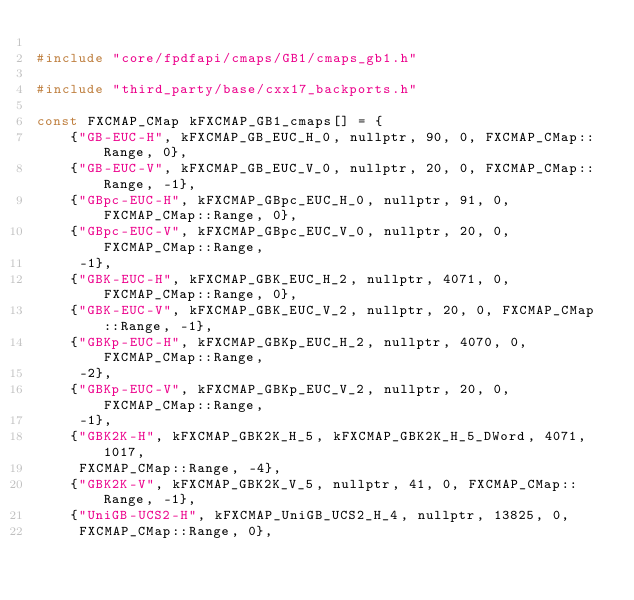<code> <loc_0><loc_0><loc_500><loc_500><_C++_>
#include "core/fpdfapi/cmaps/GB1/cmaps_gb1.h"

#include "third_party/base/cxx17_backports.h"

const FXCMAP_CMap kFXCMAP_GB1_cmaps[] = {
    {"GB-EUC-H", kFXCMAP_GB_EUC_H_0, nullptr, 90, 0, FXCMAP_CMap::Range, 0},
    {"GB-EUC-V", kFXCMAP_GB_EUC_V_0, nullptr, 20, 0, FXCMAP_CMap::Range, -1},
    {"GBpc-EUC-H", kFXCMAP_GBpc_EUC_H_0, nullptr, 91, 0, FXCMAP_CMap::Range, 0},
    {"GBpc-EUC-V", kFXCMAP_GBpc_EUC_V_0, nullptr, 20, 0, FXCMAP_CMap::Range,
     -1},
    {"GBK-EUC-H", kFXCMAP_GBK_EUC_H_2, nullptr, 4071, 0, FXCMAP_CMap::Range, 0},
    {"GBK-EUC-V", kFXCMAP_GBK_EUC_V_2, nullptr, 20, 0, FXCMAP_CMap::Range, -1},
    {"GBKp-EUC-H", kFXCMAP_GBKp_EUC_H_2, nullptr, 4070, 0, FXCMAP_CMap::Range,
     -2},
    {"GBKp-EUC-V", kFXCMAP_GBKp_EUC_V_2, nullptr, 20, 0, FXCMAP_CMap::Range,
     -1},
    {"GBK2K-H", kFXCMAP_GBK2K_H_5, kFXCMAP_GBK2K_H_5_DWord, 4071, 1017,
     FXCMAP_CMap::Range, -4},
    {"GBK2K-V", kFXCMAP_GBK2K_V_5, nullptr, 41, 0, FXCMAP_CMap::Range, -1},
    {"UniGB-UCS2-H", kFXCMAP_UniGB_UCS2_H_4, nullptr, 13825, 0,
     FXCMAP_CMap::Range, 0},</code> 